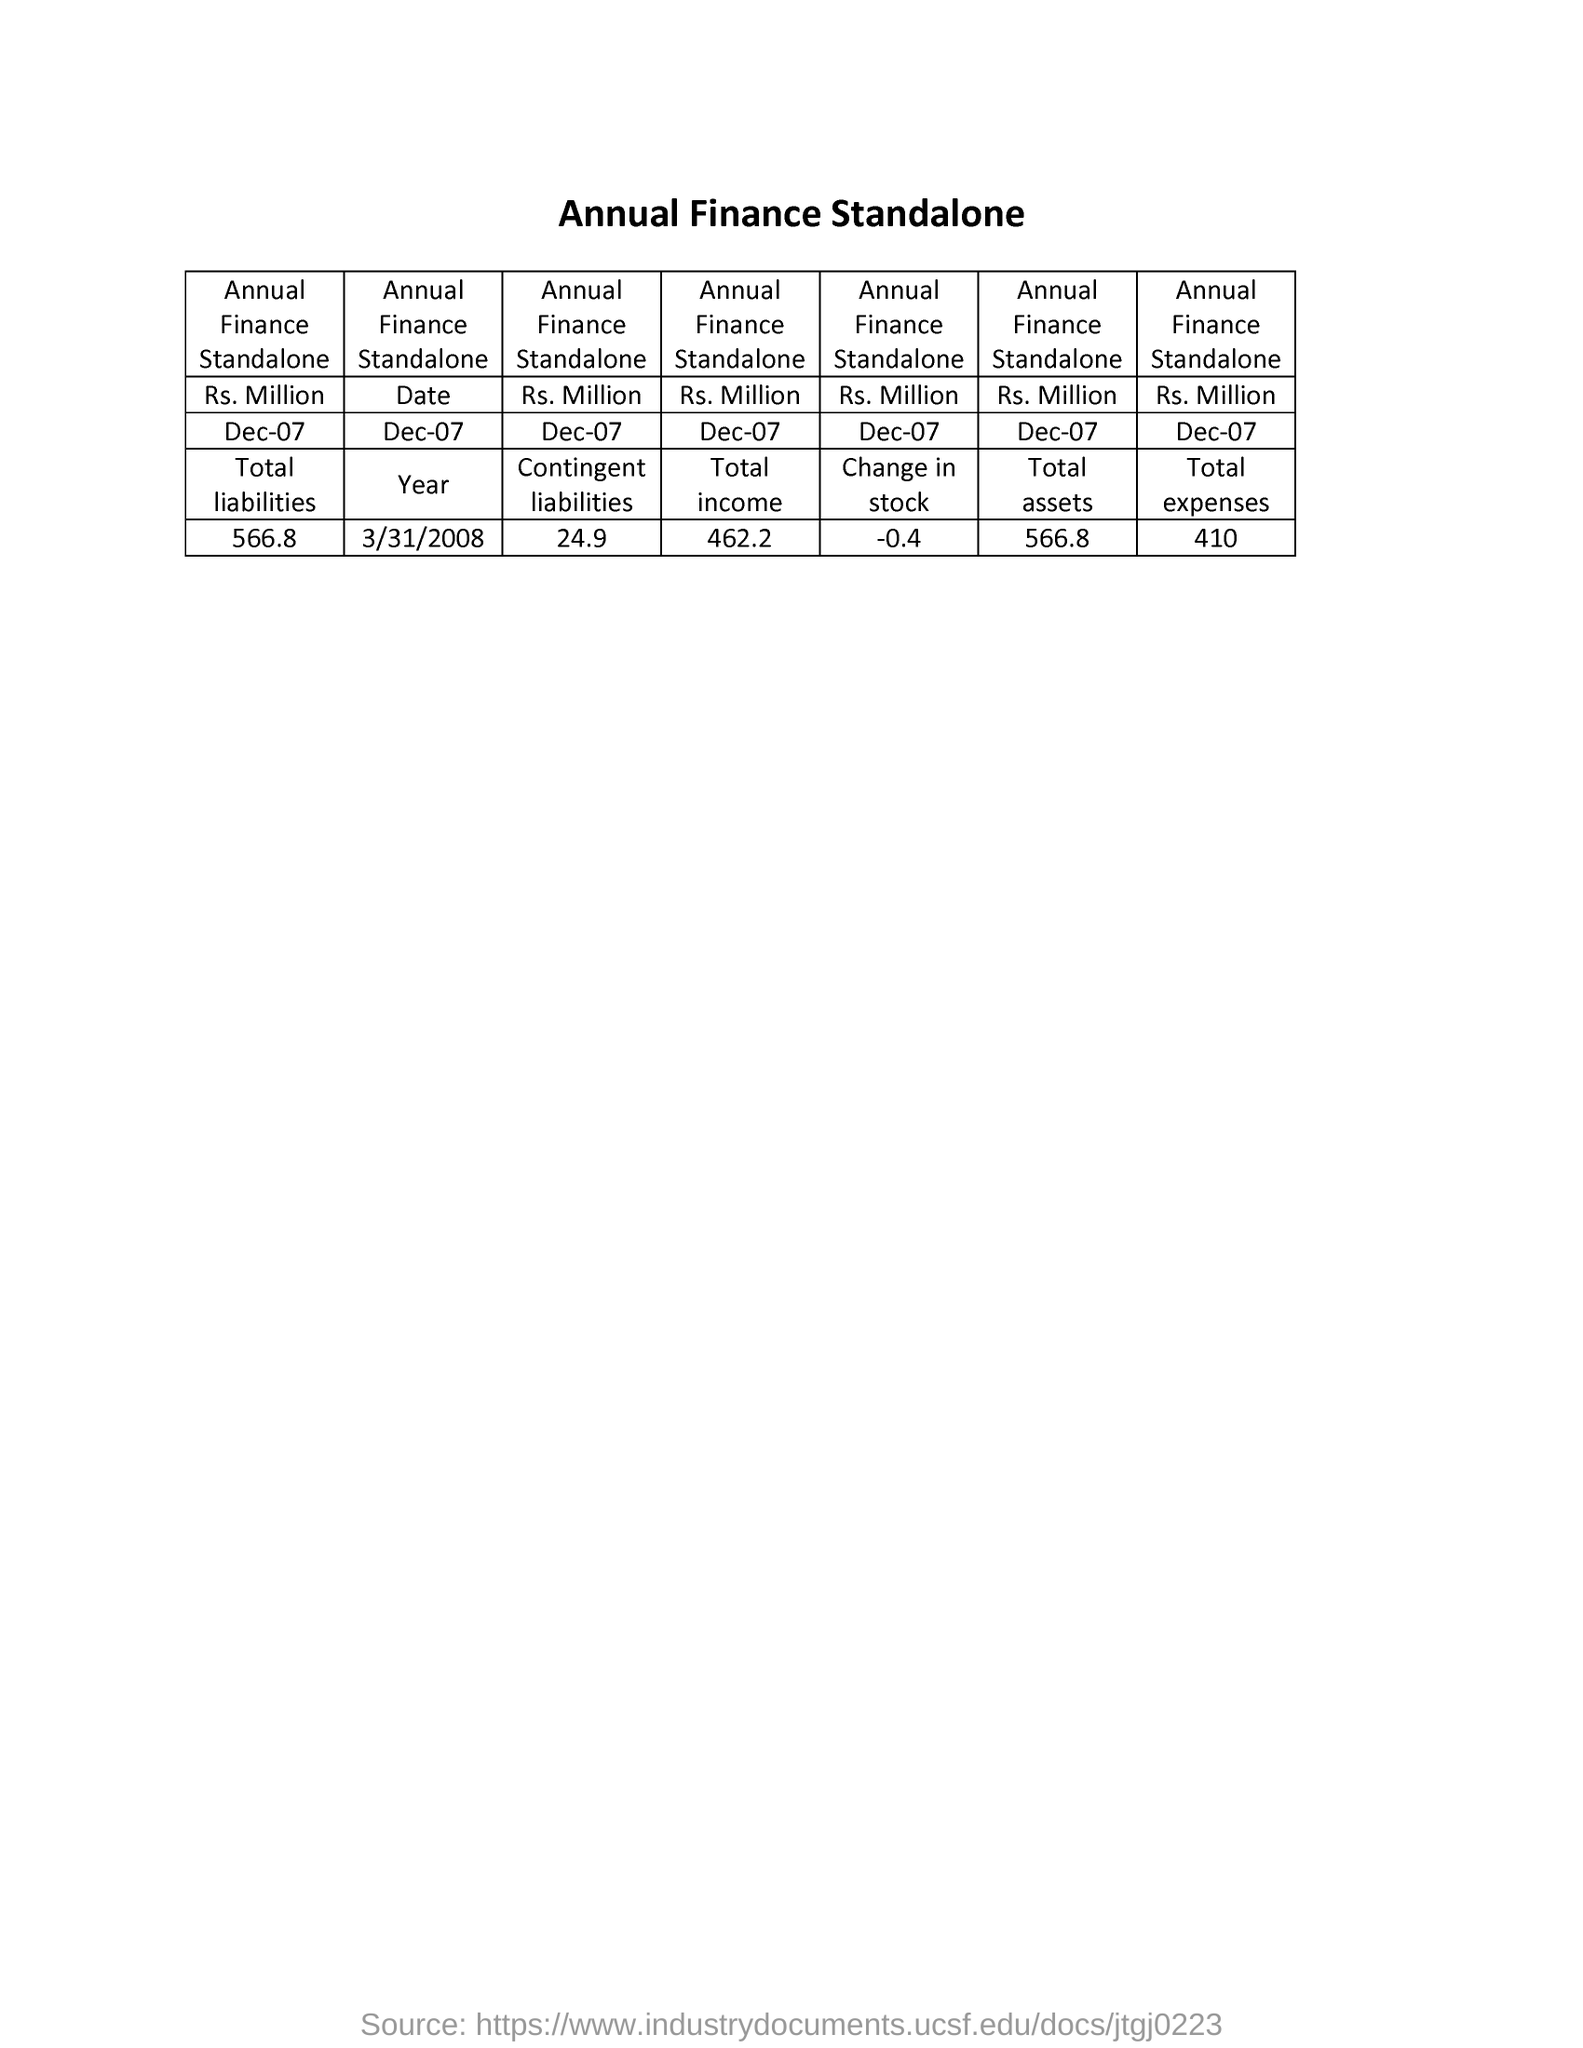How much is the total liabilities for Dec 07
Offer a terse response. 566.8. How much is the Contingent liabilities?
Offer a terse response. 24.9 Rs Million. How much is the change in stock?
Your response must be concise. -0.4 Rs Million. How much is the total expenses?
Provide a short and direct response. 410 Rs Million. 